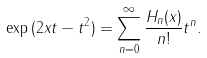<formula> <loc_0><loc_0><loc_500><loc_500>\exp { ( 2 x t - t ^ { 2 } ) } = \sum _ { n = 0 } ^ { \infty } \frac { H _ { n } ( x ) } { n ! } t ^ { n } .</formula> 